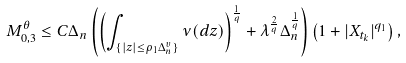<formula> <loc_0><loc_0><loc_500><loc_500>M _ { 0 , 3 } ^ { \theta } & \leq C \Delta _ { n } \left ( \left ( \int _ { \{ | z | \leq \rho _ { 1 } \Delta _ { n } ^ { \upsilon } \} } \nu ( d z ) \right ) ^ { \frac { 1 } { q } } + \lambda ^ { \frac { 2 } { q } } \Delta _ { n } ^ { \frac { 1 } { q } } \right ) \left ( 1 + | X _ { t _ { k } } | ^ { q _ { 1 } } \right ) ,</formula> 